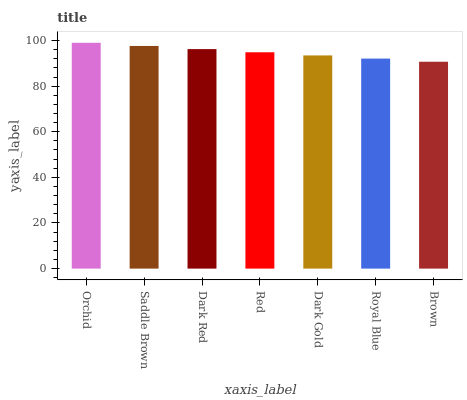Is Saddle Brown the minimum?
Answer yes or no. No. Is Saddle Brown the maximum?
Answer yes or no. No. Is Orchid greater than Saddle Brown?
Answer yes or no. Yes. Is Saddle Brown less than Orchid?
Answer yes or no. Yes. Is Saddle Brown greater than Orchid?
Answer yes or no. No. Is Orchid less than Saddle Brown?
Answer yes or no. No. Is Red the high median?
Answer yes or no. Yes. Is Red the low median?
Answer yes or no. Yes. Is Orchid the high median?
Answer yes or no. No. Is Royal Blue the low median?
Answer yes or no. No. 